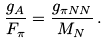Convert formula to latex. <formula><loc_0><loc_0><loc_500><loc_500>\frac { g _ { A } } { F _ { \pi } } = \frac { g _ { \pi N N } } { M _ { N } } \, .</formula> 